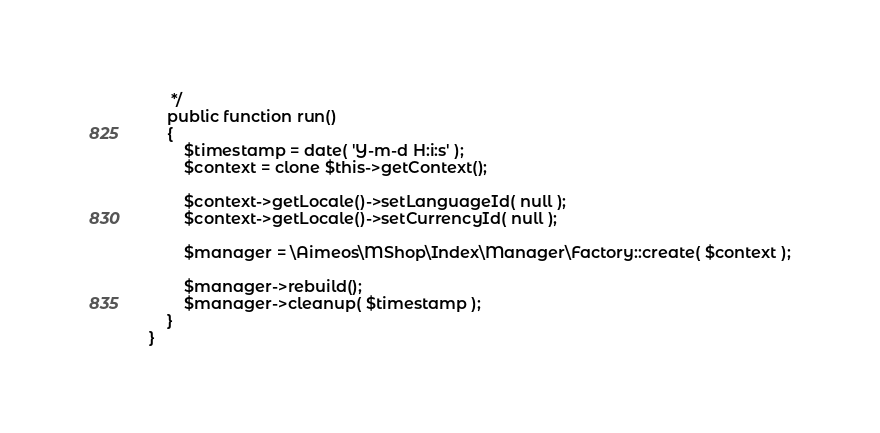<code> <loc_0><loc_0><loc_500><loc_500><_PHP_>	 */
	public function run()
	{
		$timestamp = date( 'Y-m-d H:i:s' );
		$context = clone $this->getContext();

		$context->getLocale()->setLanguageId( null );
		$context->getLocale()->setCurrencyId( null );

		$manager = \Aimeos\MShop\Index\Manager\Factory::create( $context );

		$manager->rebuild();
		$manager->cleanup( $timestamp );
	}
}
</code> 